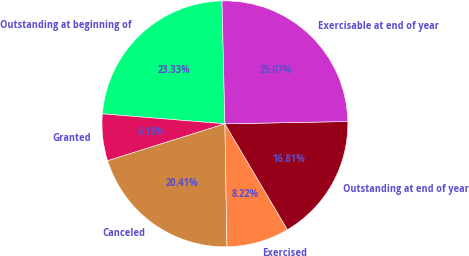Convert chart. <chart><loc_0><loc_0><loc_500><loc_500><pie_chart><fcel>Outstanding at beginning of<fcel>Granted<fcel>Canceled<fcel>Exercised<fcel>Outstanding at end of year<fcel>Exercisable at end of year<nl><fcel>23.33%<fcel>6.15%<fcel>20.41%<fcel>8.22%<fcel>16.81%<fcel>25.07%<nl></chart> 